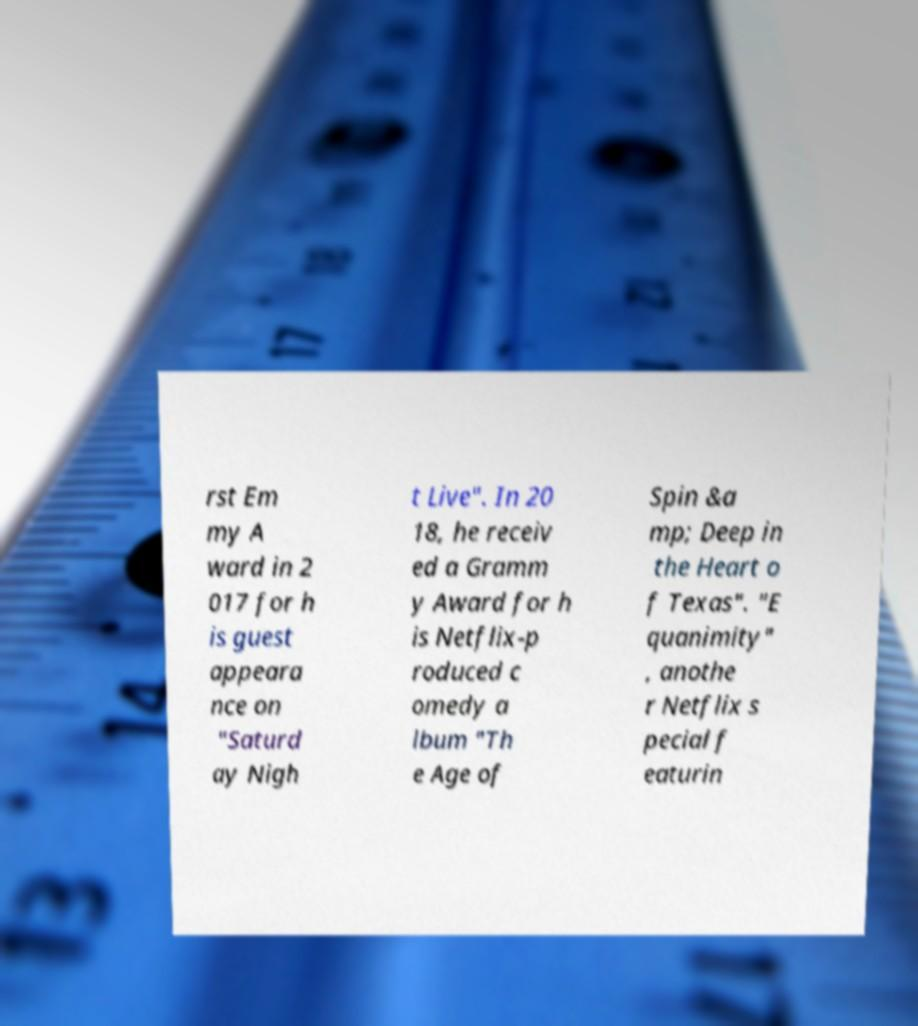Please read and relay the text visible in this image. What does it say? rst Em my A ward in 2 017 for h is guest appeara nce on "Saturd ay Nigh t Live". In 20 18, he receiv ed a Gramm y Award for h is Netflix-p roduced c omedy a lbum "Th e Age of Spin &a mp; Deep in the Heart o f Texas". "E quanimity" , anothe r Netflix s pecial f eaturin 